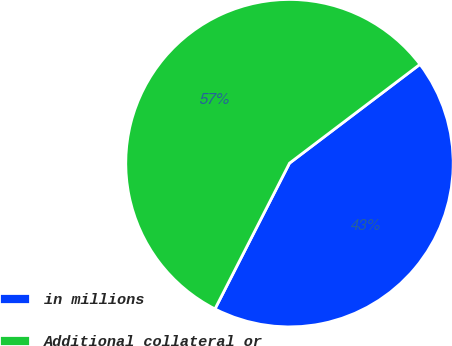Convert chart. <chart><loc_0><loc_0><loc_500><loc_500><pie_chart><fcel>in millions<fcel>Additional collateral or<nl><fcel>42.84%<fcel>57.16%<nl></chart> 